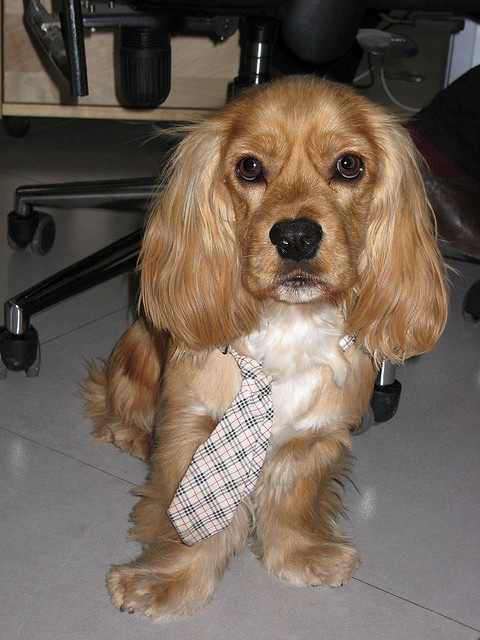Describe the objects in this image and their specific colors. I can see dog in maroon, gray, tan, brown, and lightgray tones, chair in maroon, black, and gray tones, and tie in maroon, lightgray, darkgray, pink, and gray tones in this image. 